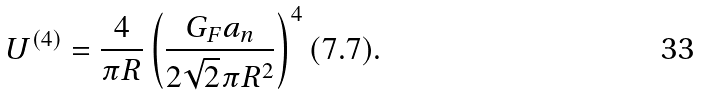Convert formula to latex. <formula><loc_0><loc_0><loc_500><loc_500>U ^ { ( 4 ) } = \frac { 4 } { \pi R } \left ( \frac { G _ { F } a _ { n } } { 2 \sqrt { 2 } \pi R ^ { 2 } } \right ) ^ { 4 } ( 7 . 7 ) .</formula> 